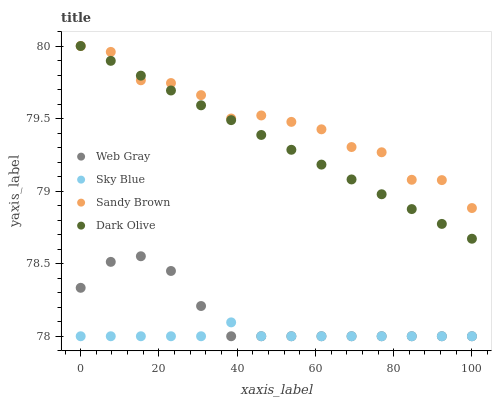Does Sky Blue have the minimum area under the curve?
Answer yes or no. Yes. Does Sandy Brown have the maximum area under the curve?
Answer yes or no. Yes. Does Web Gray have the minimum area under the curve?
Answer yes or no. No. Does Web Gray have the maximum area under the curve?
Answer yes or no. No. Is Dark Olive the smoothest?
Answer yes or no. Yes. Is Sandy Brown the roughest?
Answer yes or no. Yes. Is Sky Blue the smoothest?
Answer yes or no. No. Is Sky Blue the roughest?
Answer yes or no. No. Does Sky Blue have the lowest value?
Answer yes or no. Yes. Does Sandy Brown have the lowest value?
Answer yes or no. No. Does Sandy Brown have the highest value?
Answer yes or no. Yes. Does Web Gray have the highest value?
Answer yes or no. No. Is Web Gray less than Dark Olive?
Answer yes or no. Yes. Is Dark Olive greater than Web Gray?
Answer yes or no. Yes. Does Sandy Brown intersect Dark Olive?
Answer yes or no. Yes. Is Sandy Brown less than Dark Olive?
Answer yes or no. No. Is Sandy Brown greater than Dark Olive?
Answer yes or no. No. Does Web Gray intersect Dark Olive?
Answer yes or no. No. 